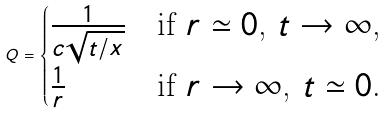Convert formula to latex. <formula><loc_0><loc_0><loc_500><loc_500>Q = \begin{cases} \frac { 1 } { c \sqrt { t / x } } & \text {if $r\simeq 0$, $t \to \infty$,} \\ \frac { 1 } { r } & \text {if $r \to \infty$, $t \simeq 0$.} \end{cases}</formula> 